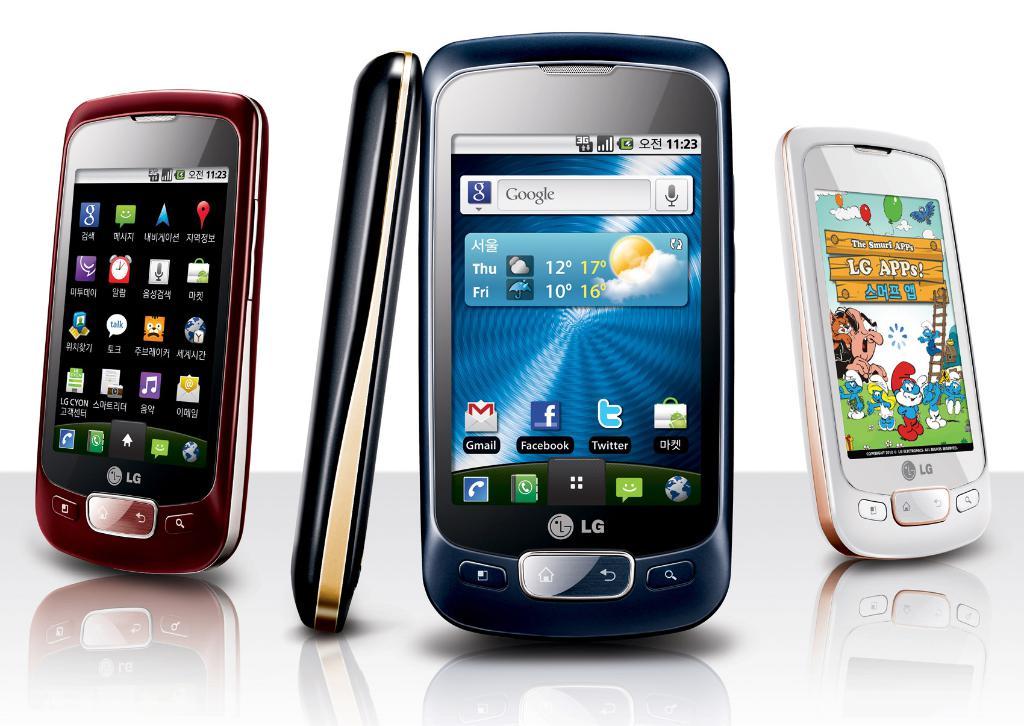What brand of phones are these?
Offer a very short reply. Lg. What time is it according to these phones?
Your answer should be compact. 11:23. 